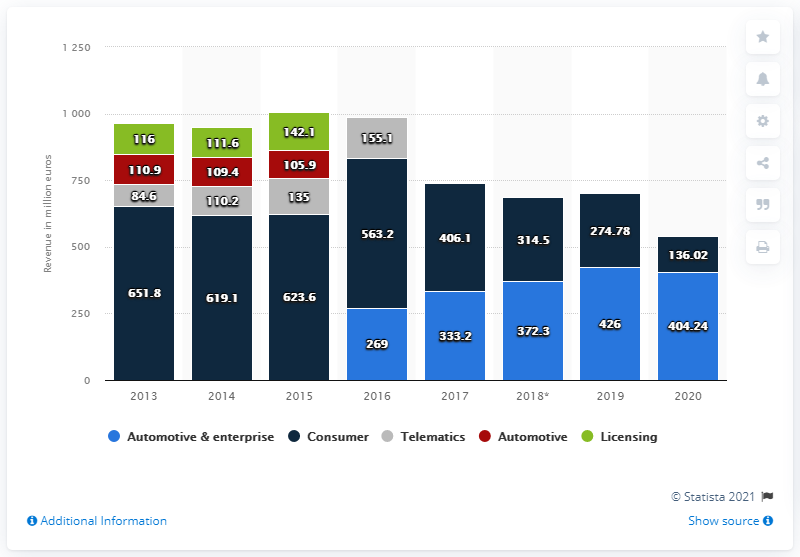Mention a couple of crucial points in this snapshot. In 2020, TomTom generated a total revenue of 404.24 million euros. 